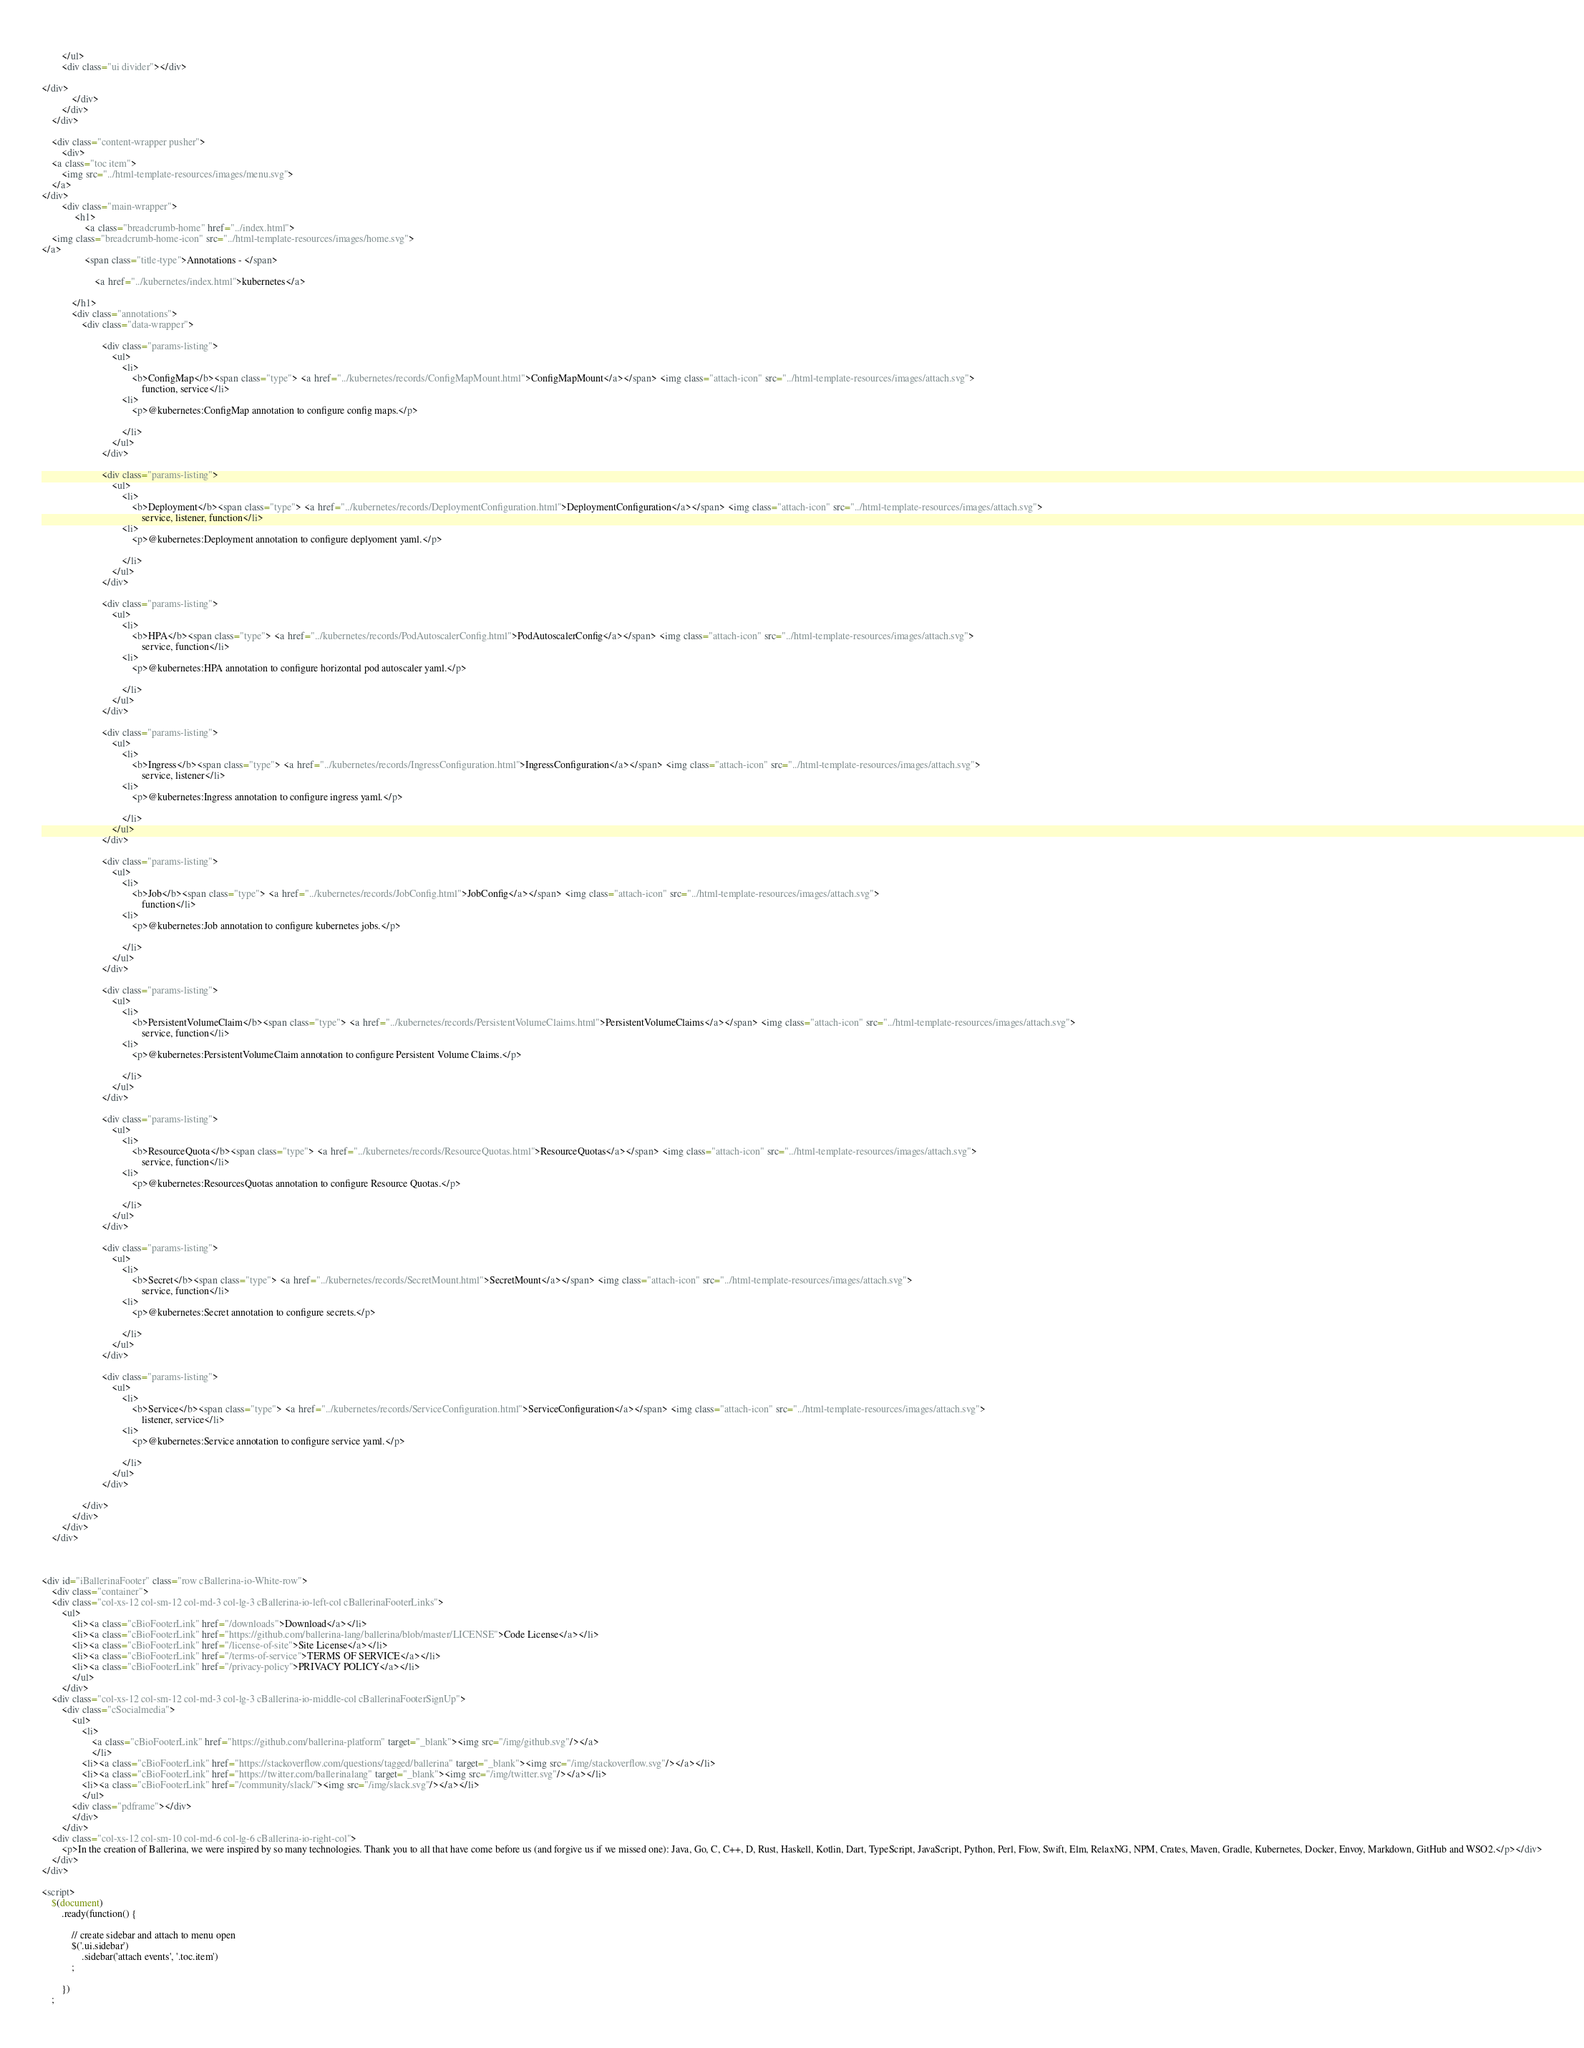<code> <loc_0><loc_0><loc_500><loc_500><_HTML_>            
        </ul>
        <div class="ui divider"></div>
    
</div>
            </div>
        </div>
    </div>

    <div class="content-wrapper pusher">
        <div>
    <a class="toc item"> 
        <img src="../html-template-resources/images/menu.svg">
    </a>
</div>
        <div class="main-wrapper">
             <h1>
                 <a class="breadcrumb-home" href="../index.html">
    <img class="breadcrumb-home-icon" src="../html-template-resources/images/home.svg">
</a>
                 <span class="title-type">Annotations - </span>
                 
                     <a href="../kubernetes/index.html">kubernetes</a>
                 
            </h1>
            <div class="annotations">
                <div class="data-wrapper">
                    
                        <div class="params-listing">
                            <ul>
                                <li>
                                    <b>ConfigMap</b><span class="type"> <a href="../kubernetes/records/ConfigMapMount.html">ConfigMapMount</a></span> <img class="attach-icon" src="../html-template-resources/images/attach.svg">
                                        function, service</li>
                                <li>
                                    <p>@kubernetes:ConfigMap annotation to configure config maps.</p>

                                </li>
                            </ul>
                        </div>
                    
                        <div class="params-listing">
                            <ul>
                                <li>
                                    <b>Deployment</b><span class="type"> <a href="../kubernetes/records/DeploymentConfiguration.html">DeploymentConfiguration</a></span> <img class="attach-icon" src="../html-template-resources/images/attach.svg">
                                        service, listener, function</li>
                                <li>
                                    <p>@kubernetes:Deployment annotation to configure deplyoment yaml.</p>

                                </li>
                            </ul>
                        </div>
                    
                        <div class="params-listing">
                            <ul>
                                <li>
                                    <b>HPA</b><span class="type"> <a href="../kubernetes/records/PodAutoscalerConfig.html">PodAutoscalerConfig</a></span> <img class="attach-icon" src="../html-template-resources/images/attach.svg">
                                        service, function</li>
                                <li>
                                    <p>@kubernetes:HPA annotation to configure horizontal pod autoscaler yaml.</p>

                                </li>
                            </ul>
                        </div>
                    
                        <div class="params-listing">
                            <ul>
                                <li>
                                    <b>Ingress</b><span class="type"> <a href="../kubernetes/records/IngressConfiguration.html">IngressConfiguration</a></span> <img class="attach-icon" src="../html-template-resources/images/attach.svg">
                                        service, listener</li>
                                <li>
                                    <p>@kubernetes:Ingress annotation to configure ingress yaml.</p>

                                </li>
                            </ul>
                        </div>
                    
                        <div class="params-listing">
                            <ul>
                                <li>
                                    <b>Job</b><span class="type"> <a href="../kubernetes/records/JobConfig.html">JobConfig</a></span> <img class="attach-icon" src="../html-template-resources/images/attach.svg">
                                        function</li>
                                <li>
                                    <p>@kubernetes:Job annotation to configure kubernetes jobs.</p>

                                </li>
                            </ul>
                        </div>
                    
                        <div class="params-listing">
                            <ul>
                                <li>
                                    <b>PersistentVolumeClaim</b><span class="type"> <a href="../kubernetes/records/PersistentVolumeClaims.html">PersistentVolumeClaims</a></span> <img class="attach-icon" src="../html-template-resources/images/attach.svg">
                                        service, function</li>
                                <li>
                                    <p>@kubernetes:PersistentVolumeClaim annotation to configure Persistent Volume Claims.</p>

                                </li>
                            </ul>
                        </div>
                    
                        <div class="params-listing">
                            <ul>
                                <li>
                                    <b>ResourceQuota</b><span class="type"> <a href="../kubernetes/records/ResourceQuotas.html">ResourceQuotas</a></span> <img class="attach-icon" src="../html-template-resources/images/attach.svg">
                                        service, function</li>
                                <li>
                                    <p>@kubernetes:ResourcesQuotas annotation to configure Resource Quotas.</p>

                                </li>
                            </ul>
                        </div>
                    
                        <div class="params-listing">
                            <ul>
                                <li>
                                    <b>Secret</b><span class="type"> <a href="../kubernetes/records/SecretMount.html">SecretMount</a></span> <img class="attach-icon" src="../html-template-resources/images/attach.svg">
                                        service, function</li>
                                <li>
                                    <p>@kubernetes:Secret annotation to configure secrets.</p>

                                </li>
                            </ul>
                        </div>
                    
                        <div class="params-listing">
                            <ul>
                                <li>
                                    <b>Service</b><span class="type"> <a href="../kubernetes/records/ServiceConfiguration.html">ServiceConfiguration</a></span> <img class="attach-icon" src="../html-template-resources/images/attach.svg">
                                        listener, service</li>
                                <li>
                                    <p>@kubernetes:Service annotation to configure service yaml.</p>

                                </li>
                            </ul>
                        </div>
                    
                </div>
            </div>
        </div>
    </div>



<div id="iBallerinaFooter" class="row cBallerina-io-White-row">
    <div class="container">
    <div class="col-xs-12 col-sm-12 col-md-3 col-lg-3 cBallerina-io-left-col cBallerinaFooterLinks">
        <ul>
            <li><a class="cBioFooterLink" href="/downloads">Download</a></li>
            <li><a class="cBioFooterLink" href="https://github.com/ballerina-lang/ballerina/blob/master/LICENSE">Code License</a></li>
            <li><a class="cBioFooterLink" href="/license-of-site">Site License</a></li>
            <li><a class="cBioFooterLink" href="/terms-of-service">TERMS OF SERVICE</a></li>
            <li><a class="cBioFooterLink" href="/privacy-policy">PRIVACY POLICY</a></li>
            </ul>
        </div>
    <div class="col-xs-12 col-sm-12 col-md-3 col-lg-3 cBallerina-io-middle-col cBallerinaFooterSignUp">
        <div class="cSocialmedia">
            <ul>
                <li>
                    <a class="cBioFooterLink" href="https://github.com/ballerina-platform" target="_blank"><img src="/img/github.svg"/></a>
                    </li>
                <li><a class="cBioFooterLink" href="https://stackoverflow.com/questions/tagged/ballerina" target="_blank"><img src="/img/stackoverflow.svg"/></a></li>
                <li><a class="cBioFooterLink" href="https://twitter.com/ballerinalang" target="_blank"><img src="/img/twitter.svg"/></a></li>
                <li><a class="cBioFooterLink" href="/community/slack/"><img src="/img/slack.svg"/></a></li>
                </ul>
            <div class="pdframe"></div>
            </div>
        </div>
    <div class="col-xs-12 col-sm-10 col-md-6 col-lg-6 cBallerina-io-right-col">
        <p>In the creation of Ballerina, we were inspired by so many technologies. Thank you to all that have come before us (and forgive us if we missed one): Java, Go, C, C++, D, Rust, Haskell, Kotlin, Dart, TypeScript, JavaScript, Python, Perl, Flow, Swift, Elm, RelaxNG, NPM, Crates, Maven, Gradle, Kubernetes, Docker, Envoy, Markdown, GitHub and WSO2.</p></div>
    </div>
</div>

<script>
    $(document)
        .ready(function() {

            // create sidebar and attach to menu open
            $('.ui.sidebar')
                .sidebar('attach events', '.toc.item')
            ;

        })
    ;
</code> 